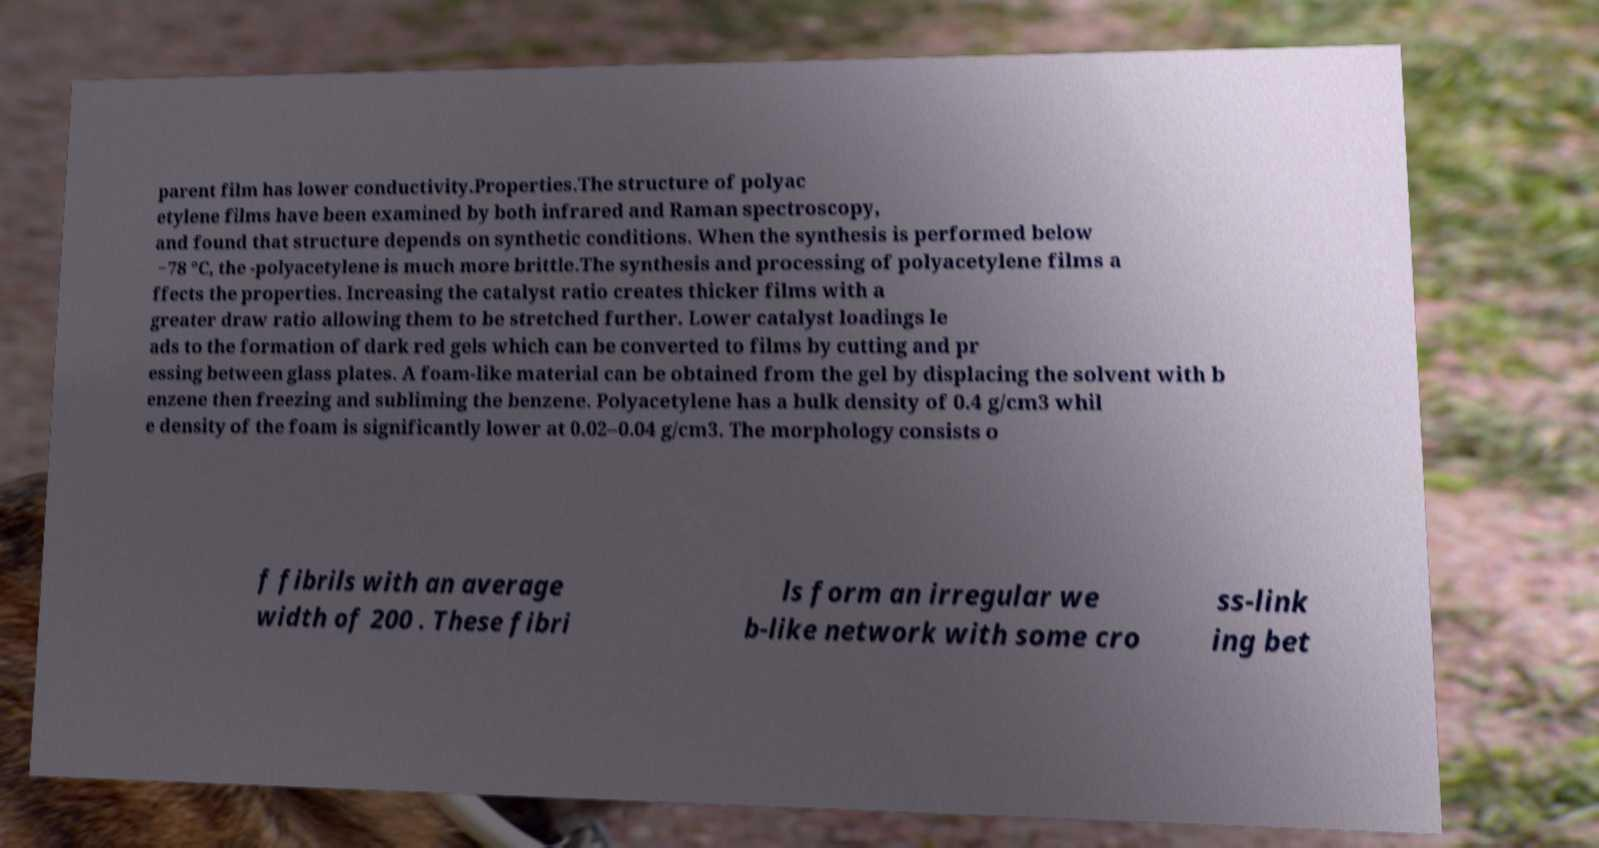Could you extract and type out the text from this image? parent film has lower conductivity.Properties.The structure of polyac etylene films have been examined by both infrared and Raman spectroscopy, and found that structure depends on synthetic conditions. When the synthesis is performed below −78 °C, the -polyacetylene is much more brittle.The synthesis and processing of polyacetylene films a ffects the properties. Increasing the catalyst ratio creates thicker films with a greater draw ratio allowing them to be stretched further. Lower catalyst loadings le ads to the formation of dark red gels which can be converted to films by cutting and pr essing between glass plates. A foam-like material can be obtained from the gel by displacing the solvent with b enzene then freezing and subliming the benzene. Polyacetylene has a bulk density of 0.4 g/cm3 whil e density of the foam is significantly lower at 0.02–0.04 g/cm3. The morphology consists o f fibrils with an average width of 200 . These fibri ls form an irregular we b-like network with some cro ss-link ing bet 